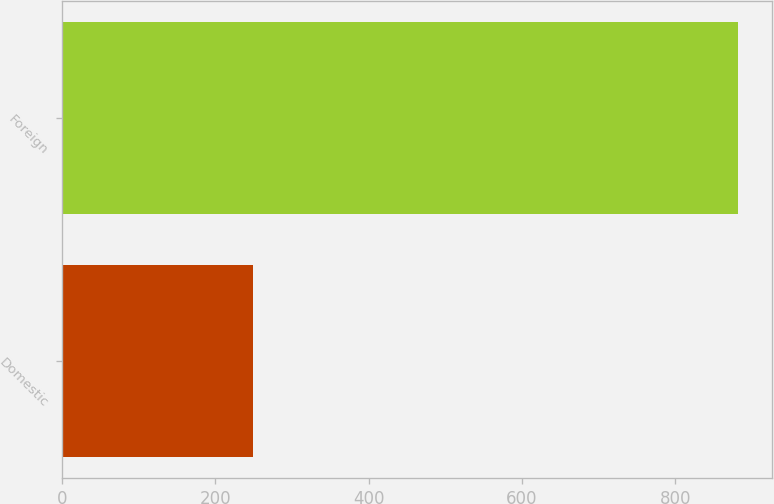Convert chart to OTSL. <chart><loc_0><loc_0><loc_500><loc_500><bar_chart><fcel>Domestic<fcel>Foreign<nl><fcel>249.7<fcel>881.8<nl></chart> 